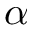<formula> <loc_0><loc_0><loc_500><loc_500>\alpha</formula> 